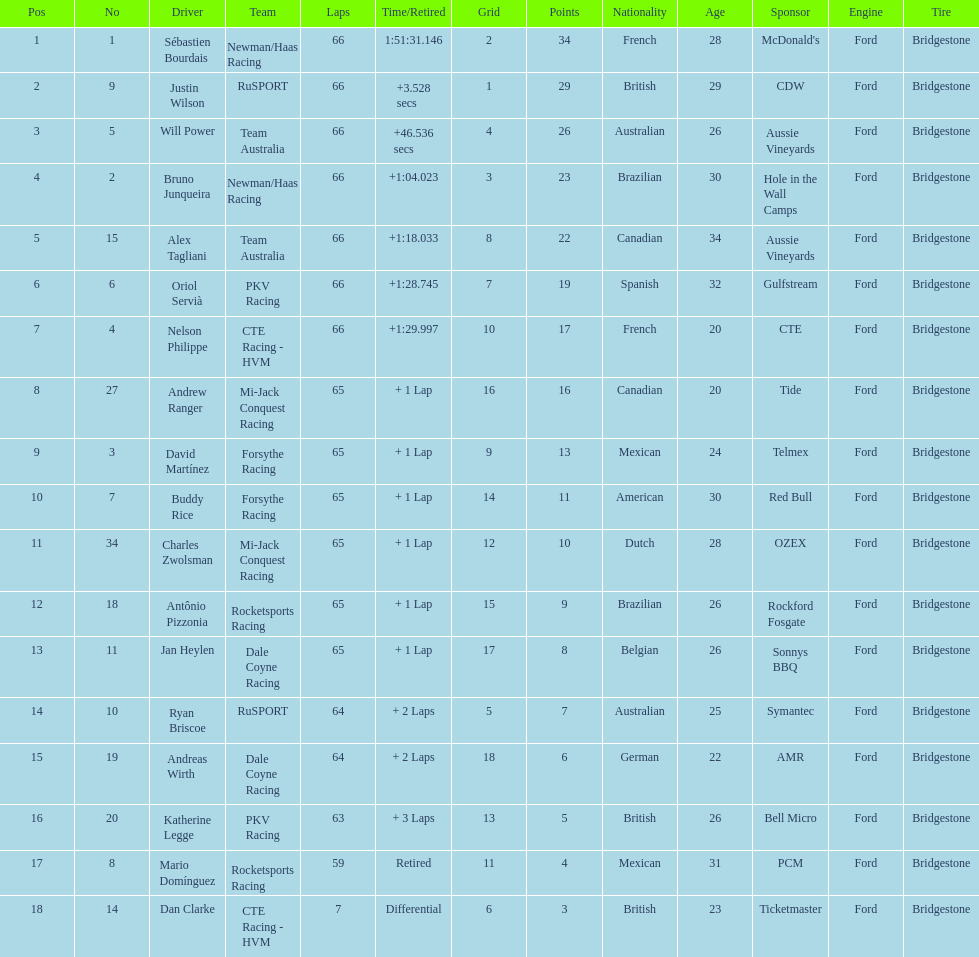At the 2006 gran premio telmex, did oriol servia or katherine legge complete more laps? Oriol Servià. 